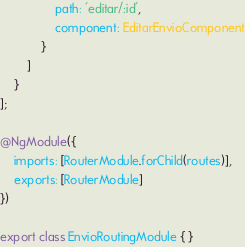Convert code to text. <code><loc_0><loc_0><loc_500><loc_500><_TypeScript_>                path: 'editar/:id',
                component: EditarEnvioComponent
            }
        ]
    }
];

@NgModule({
    imports: [RouterModule.forChild(routes)],
    exports: [RouterModule]
})

export class EnvioRoutingModule { }
</code> 